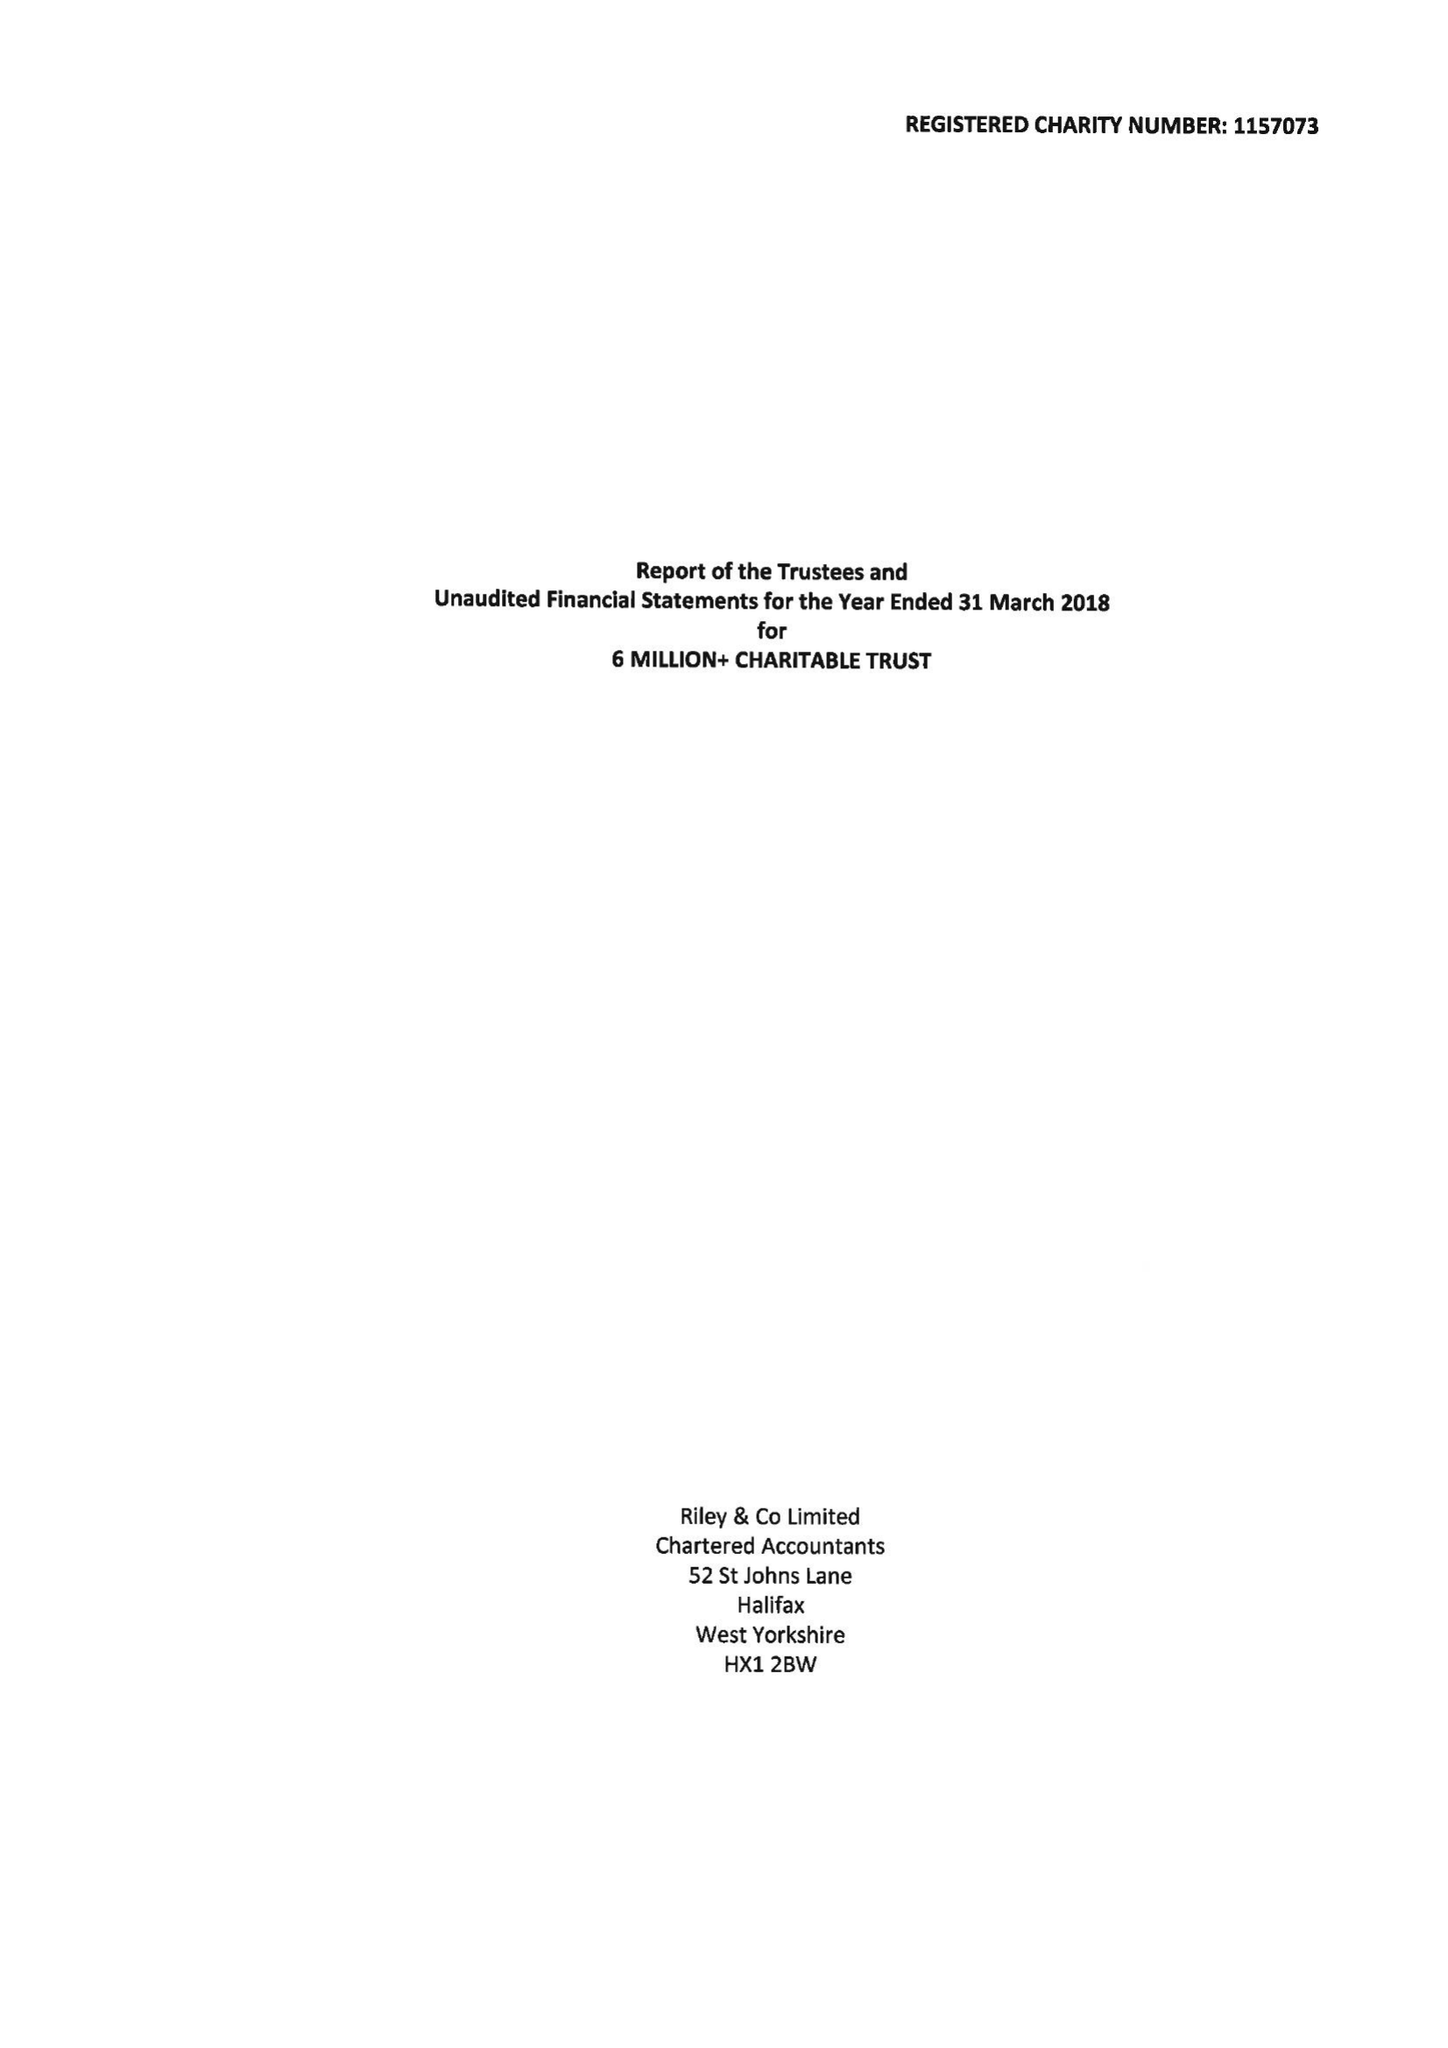What is the value for the address__post_town?
Answer the question using a single word or phrase. HUDDERSFIELD 